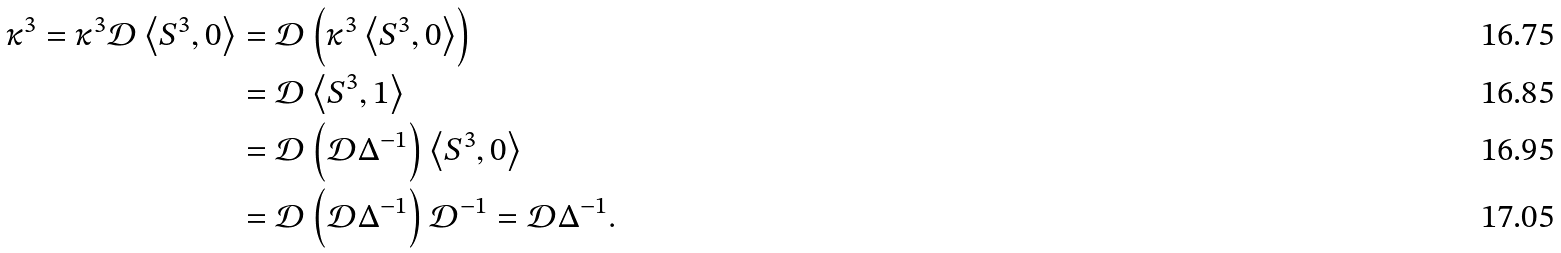<formula> <loc_0><loc_0><loc_500><loc_500>\kappa ^ { 3 } = \kappa ^ { 3 } \mathcal { D } \left \langle S ^ { 3 } , 0 \right \rangle & = \mathcal { D } \left ( \kappa ^ { 3 } \left \langle S ^ { 3 } , 0 \right \rangle \right ) \\ & = \mathcal { D } \left \langle S ^ { 3 } , 1 \right \rangle \\ & = \mathcal { D } \left ( \mathcal { D } \Delta ^ { - 1 } \right ) \left \langle S ^ { 3 } , 0 \right \rangle \\ & = \mathcal { D } \left ( \mathcal { D } \Delta ^ { - 1 } \right ) \mathcal { D } ^ { - 1 } = \mathcal { D } \Delta ^ { - 1 } .</formula> 